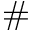Convert formula to latex. <formula><loc_0><loc_0><loc_500><loc_500>\#</formula> 